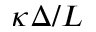<formula> <loc_0><loc_0><loc_500><loc_500>\kappa \Delta / L</formula> 